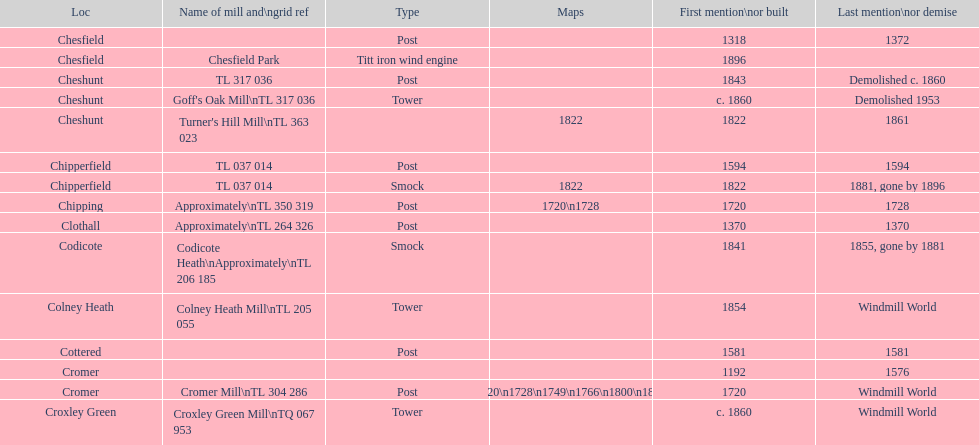In which location can the most maps be found? Cromer. 